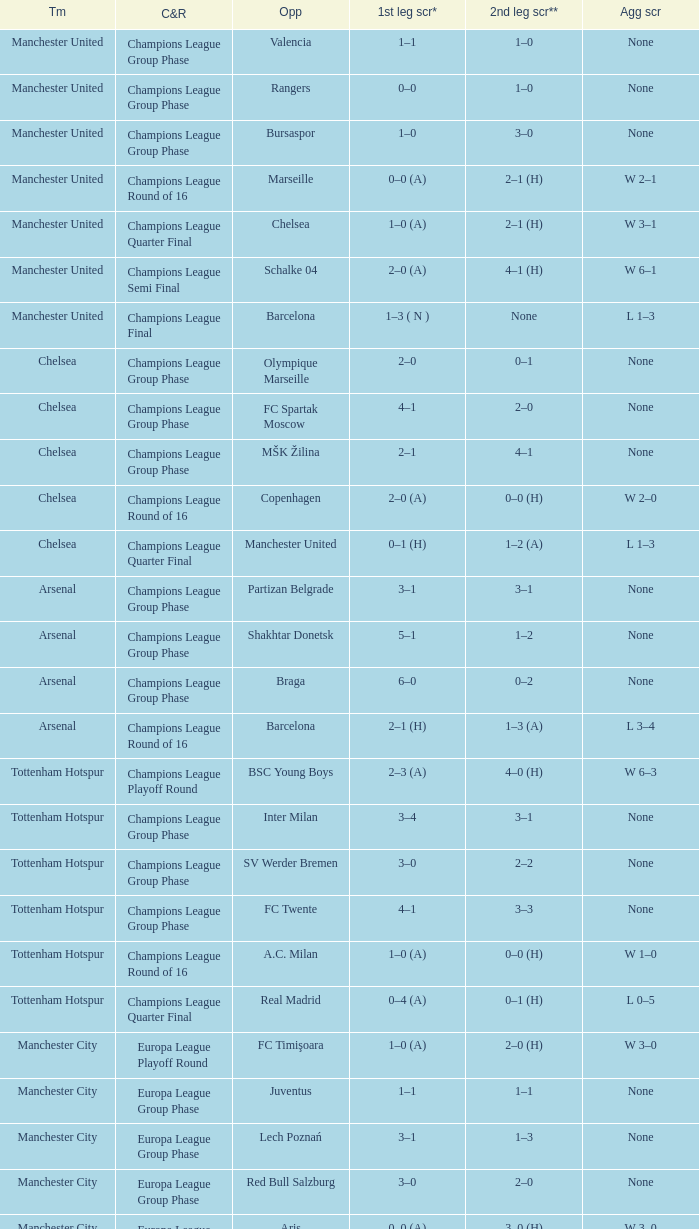How many goals did each team score in the first leg of the match between Liverpool and Steaua Bucureşti? 4–1. 